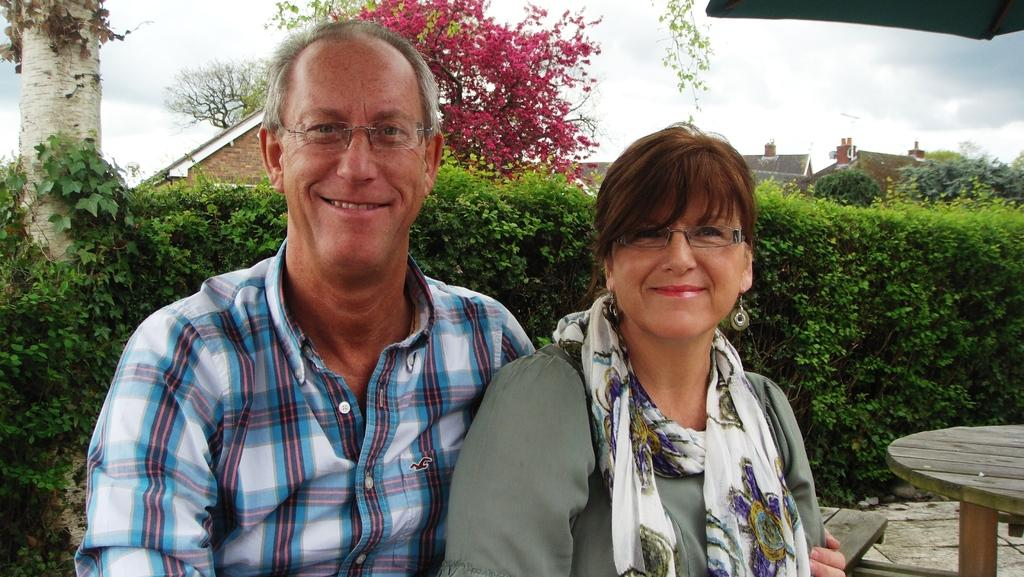How many people are present in the image? There are two people, a man and a woman, present in the image. What expressions do the man and the woman have in the image? Both the man and the woman are smiling in the image. What can be seen in the background of the image? There are plants, trees, and buildings in the background of the image. What type of soap is the man using to wash his hands in the image? There is no soap or hand-washing activity depicted in the image; it only shows the man and the woman smiling. 